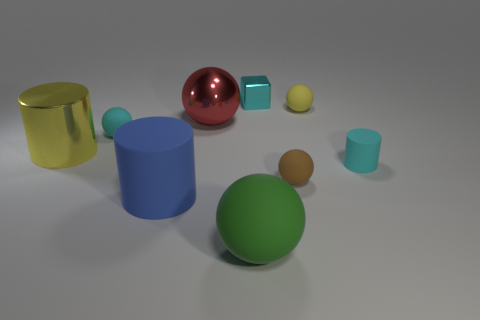What materials do the objects in the image appear to be made of? The objects’ appearances suggest a variety of materials. The reflective red sphere looks like it's made of polished metal, while the green and blue cylinders seem to have a matte finish, possibly plastic. The yellow shapes resemble solid, non-reflective objects, potentially also made of a plastic or similarly opaque material. 